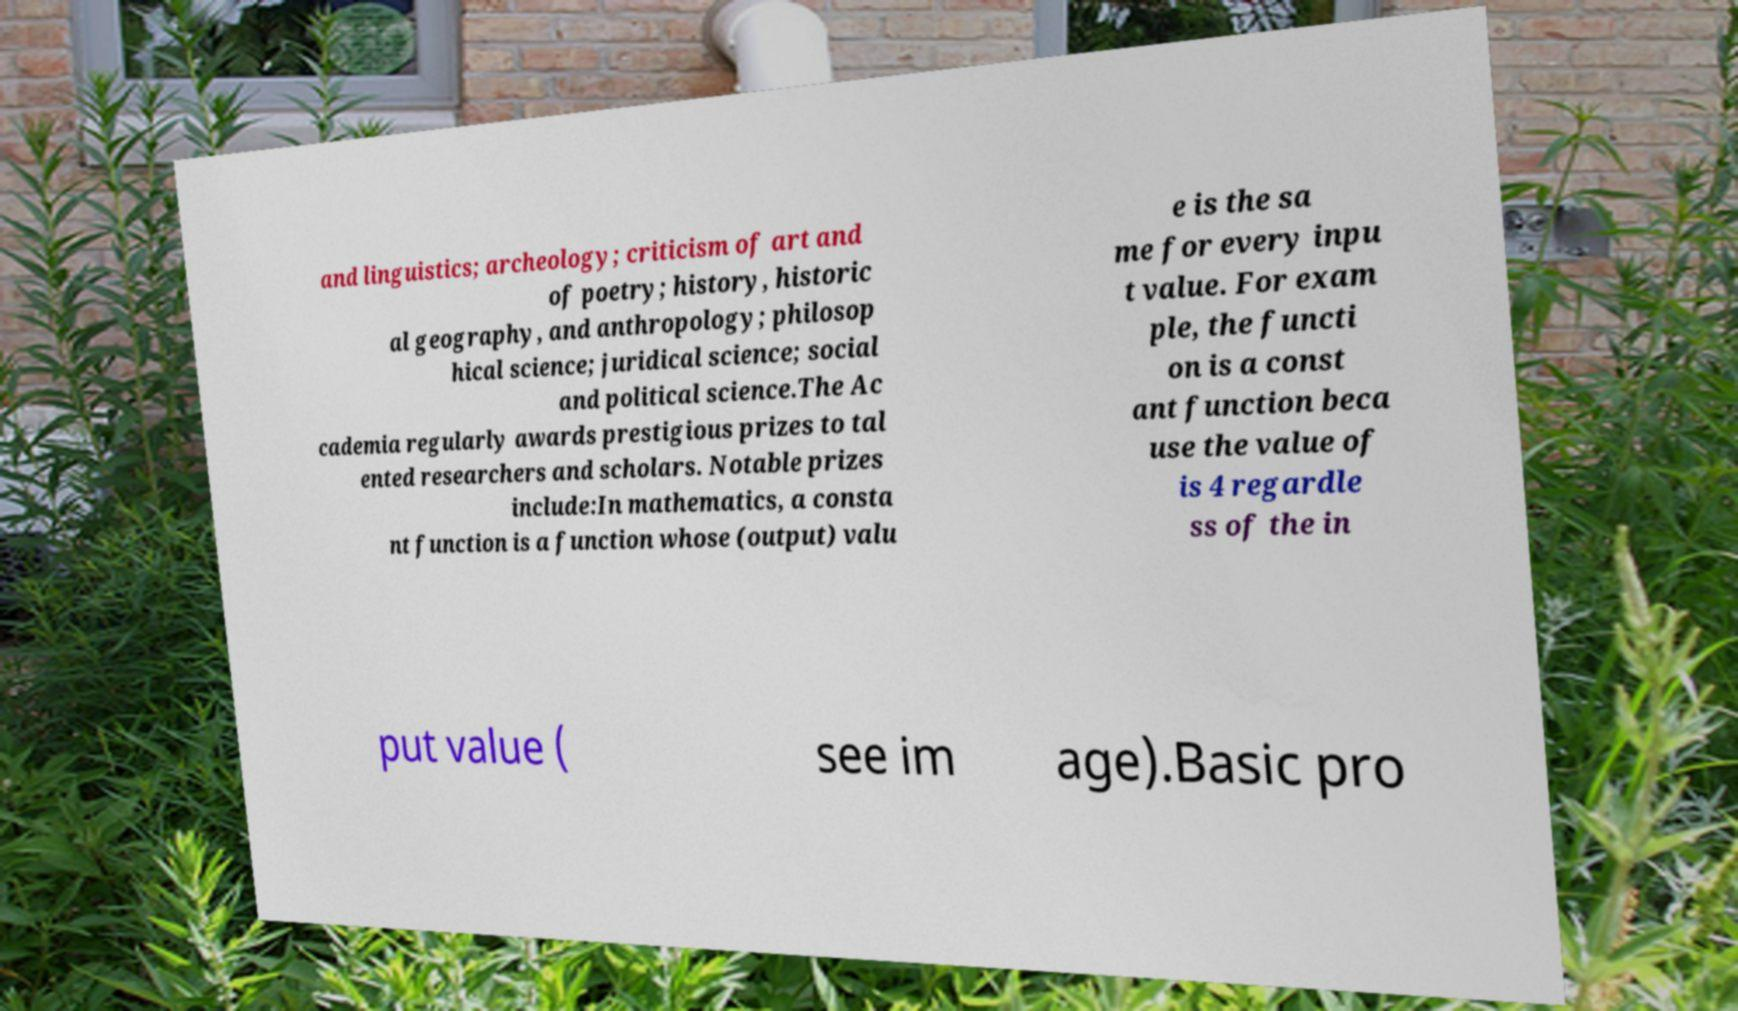There's text embedded in this image that I need extracted. Can you transcribe it verbatim? and linguistics; archeology; criticism of art and of poetry; history, historic al geography, and anthropology; philosop hical science; juridical science; social and political science.The Ac cademia regularly awards prestigious prizes to tal ented researchers and scholars. Notable prizes include:In mathematics, a consta nt function is a function whose (output) valu e is the sa me for every inpu t value. For exam ple, the functi on is a const ant function beca use the value of is 4 regardle ss of the in put value ( see im age).Basic pro 